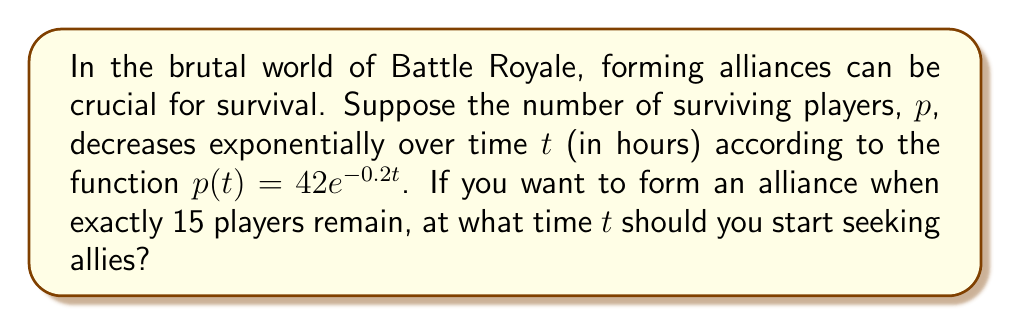Solve this math problem. To solve this problem, we need to use the given exponential function and solve for $t$ when $p(t) = 15$. Let's break it down step-by-step:

1) We start with the equation:
   $p(t) = 42e^{-0.2t}$

2) We want to find $t$ when $p(t) = 15$, so we set up the equation:
   $15 = 42e^{-0.2t}$

3) Divide both sides by 42:
   $\frac{15}{42} = e^{-0.2t}$

4) Take the natural logarithm of both sides:
   $\ln(\frac{15}{42}) = \ln(e^{-0.2t})$

5) Simplify the right side using the properties of logarithms:
   $\ln(\frac{15}{42}) = -0.2t$

6) Divide both sides by -0.2:
   $\frac{\ln(\frac{15}{42})}{-0.2} = t$

7) Calculate the value:
   $t \approx 5.22$ hours

Therefore, you should start seeking allies approximately 5.22 hours into the game when there are exactly 15 players remaining.
Answer: $t \approx 5.22$ hours 